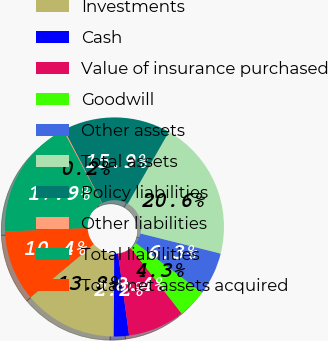<chart> <loc_0><loc_0><loc_500><loc_500><pie_chart><fcel>Investments<fcel>Cash<fcel>Value of insurance purchased<fcel>Goodwill<fcel>Other assets<fcel>Total assets<fcel>Policy liabilities<fcel>Other liabilities<fcel>Total liabilities<fcel>Total net assets acquired<nl><fcel>13.81%<fcel>2.23%<fcel>8.37%<fcel>4.27%<fcel>6.32%<fcel>20.64%<fcel>15.86%<fcel>0.18%<fcel>17.9%<fcel>10.41%<nl></chart> 